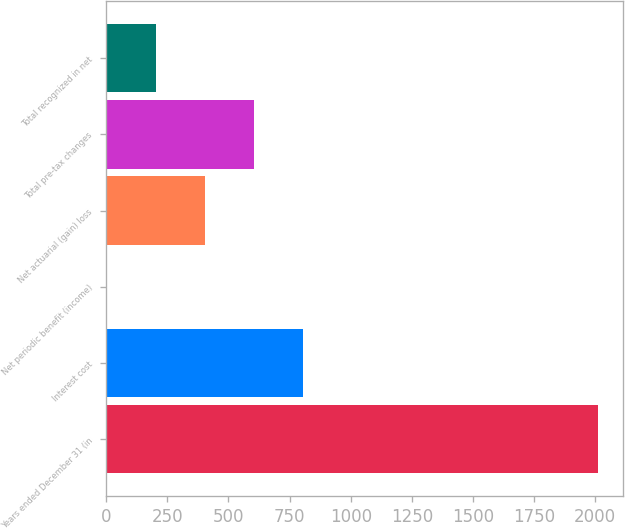<chart> <loc_0><loc_0><loc_500><loc_500><bar_chart><fcel>Years ended December 31 (in<fcel>Interest cost<fcel>Net periodic benefit (income)<fcel>Net actuarial (gain) loss<fcel>Total pre-tax changes<fcel>Total recognized in net<nl><fcel>2012<fcel>806.72<fcel>3.2<fcel>404.96<fcel>605.84<fcel>204.08<nl></chart> 